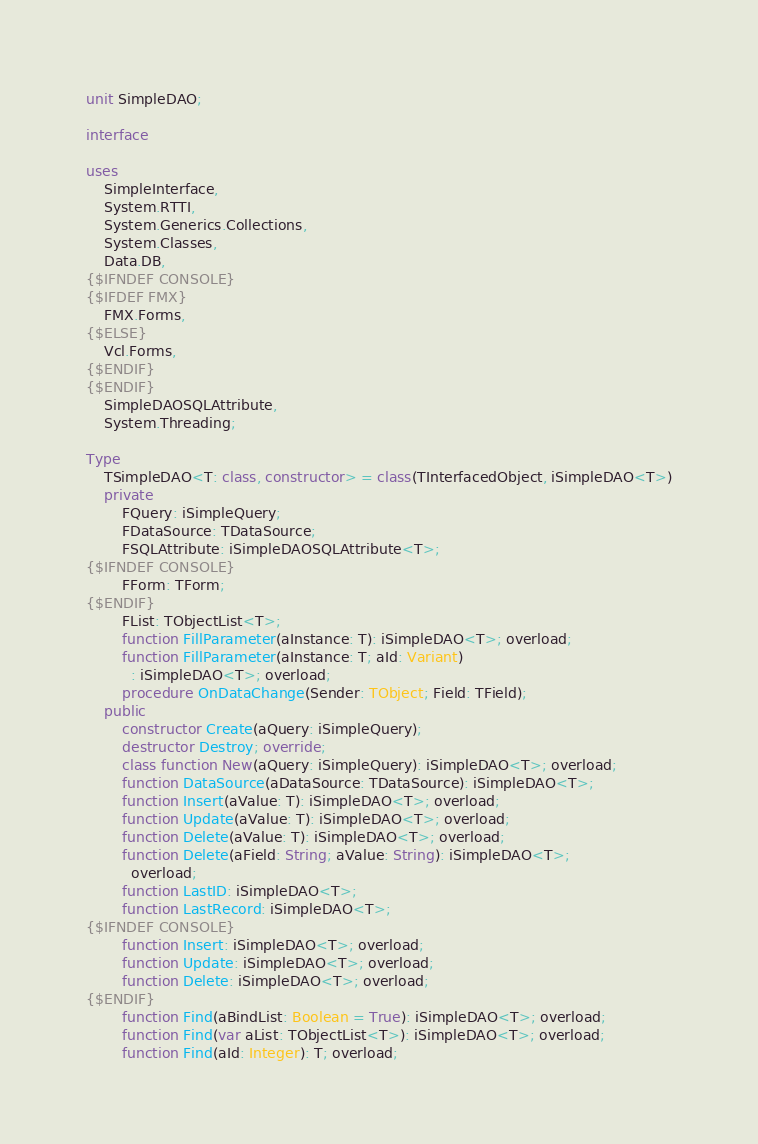Convert code to text. <code><loc_0><loc_0><loc_500><loc_500><_Pascal_>unit SimpleDAO;

interface

uses
    SimpleInterface,
    System.RTTI,
    System.Generics.Collections,
    System.Classes,
    Data.DB,
{$IFNDEF CONSOLE}
{$IFDEF FMX}
    FMX.Forms,
{$ELSE}
    Vcl.Forms,
{$ENDIF}
{$ENDIF}
    SimpleDAOSQLAttribute,
    System.Threading;

Type
    TSimpleDAO<T: class, constructor> = class(TInterfacedObject, iSimpleDAO<T>)
    private
        FQuery: iSimpleQuery;
        FDataSource: TDataSource;
        FSQLAttribute: iSimpleDAOSQLAttribute<T>;
{$IFNDEF CONSOLE}
        FForm: TForm;
{$ENDIF}
        FList: TObjectList<T>;
        function FillParameter(aInstance: T): iSimpleDAO<T>; overload;
        function FillParameter(aInstance: T; aId: Variant)
          : iSimpleDAO<T>; overload;
        procedure OnDataChange(Sender: TObject; Field: TField);
    public
        constructor Create(aQuery: iSimpleQuery);
        destructor Destroy; override;
        class function New(aQuery: iSimpleQuery): iSimpleDAO<T>; overload;
        function DataSource(aDataSource: TDataSource): iSimpleDAO<T>;
        function Insert(aValue: T): iSimpleDAO<T>; overload;
        function Update(aValue: T): iSimpleDAO<T>; overload;
        function Delete(aValue: T): iSimpleDAO<T>; overload;
        function Delete(aField: String; aValue: String): iSimpleDAO<T>;
          overload;
        function LastID: iSimpleDAO<T>;
        function LastRecord: iSimpleDAO<T>;
{$IFNDEF CONSOLE}
        function Insert: iSimpleDAO<T>; overload;
        function Update: iSimpleDAO<T>; overload;
        function Delete: iSimpleDAO<T>; overload;
{$ENDIF}
        function Find(aBindList: Boolean = True): iSimpleDAO<T>; overload;
        function Find(var aList: TObjectList<T>): iSimpleDAO<T>; overload;
        function Find(aId: Integer): T; overload;</code> 